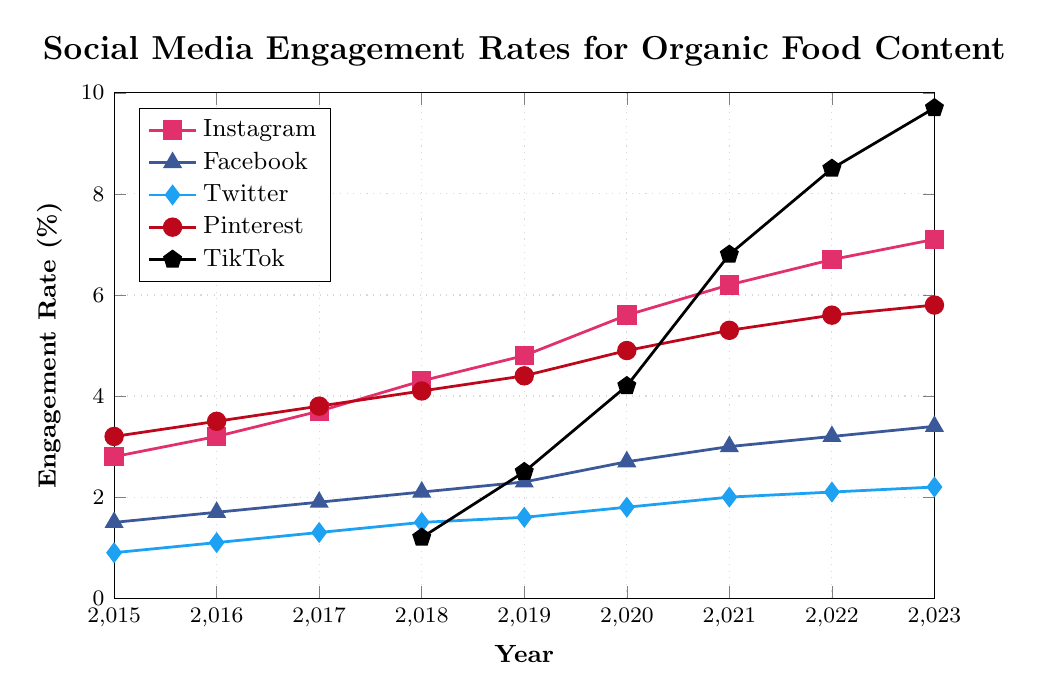What's the platform with the highest engagement rate in 2023? TikTok has the highest engagement rate in 2023 at 9.7%, followed by Instagram at 7.1%. TikTok's rate is visually seen to be the highest.
Answer: TikTok Which platform had the greatest increase in engagement rate from 2018 to 2023? To find the greatest increase, we need to compare the increase for each platform from 2018 to 2023. TikTok went from 1.2% in 2018 to 9.7% in 2023, increasing by 8.5%. The other platforms had smaller increases.
Answer: TikTok How does Instagram's engagement rate in 2023 compare to its rate in 2015? Instagram's engagement rate increased from 2.8% in 2015 to 7.1% in 2023. This is a difference of 7.1 - 2.8 = 4.3%.
Answer: 4.3% What's the overall trend in engagement rates for Twitter from 2015 to 2023? The trend for Twitter's engagement rate shows a gradual increase from 0.9% in 2015 to 2.2% in 2023, indicating a steady upward trend.
Answer: Gradual increase Which platform had the lowest engagement rate in 2015 and what was it? In 2015, Twitter had the lowest engagement rate among the platforms at 0.9%, as seen by the shortest line segment in the plot for that year.
Answer: Twitter What is the difference between the 2019 and 2023 engagement rates for Pinterest? Pinterest's engagement rate was 4.4% in 2019 and 5.8% in 2023. The difference is 5.8 - 4.4 = 1.4%.
Answer: 1.4% At what year did TikTok surpass Instagram in engagement rates? TikTok surpassed Instagram in 2021. In 2021, TikTok had an engagement rate of 6.8% compared to Instagram's 6.2%.
Answer: 2021 Calculate the average engagement rate for Facebook from 2015 to 2023. Add all the annual engagement rates for Facebook then divide by the number of years: (1.5 + 1.7 + 1.9 + 2.1 + 2.3 + 2.7 + 3.0 + 3.2 + 3.4) / 9 = 22.8 / 9 = ~2.53%.
Answer: ~2.53% Identify the years where Pinterest had a higher engagement rate than Instagram. Compare the rates year by year: Keywords to remember - only in 2015 (Pinterest 3.2% vs Instagram 2.8%), 2016 (Pinterest 3.5% vs Instagram 3.2%), and 2017 (Pinterest 3.8% vs Instagram 3.7%).
Answer: 2015, 2016, 2017 